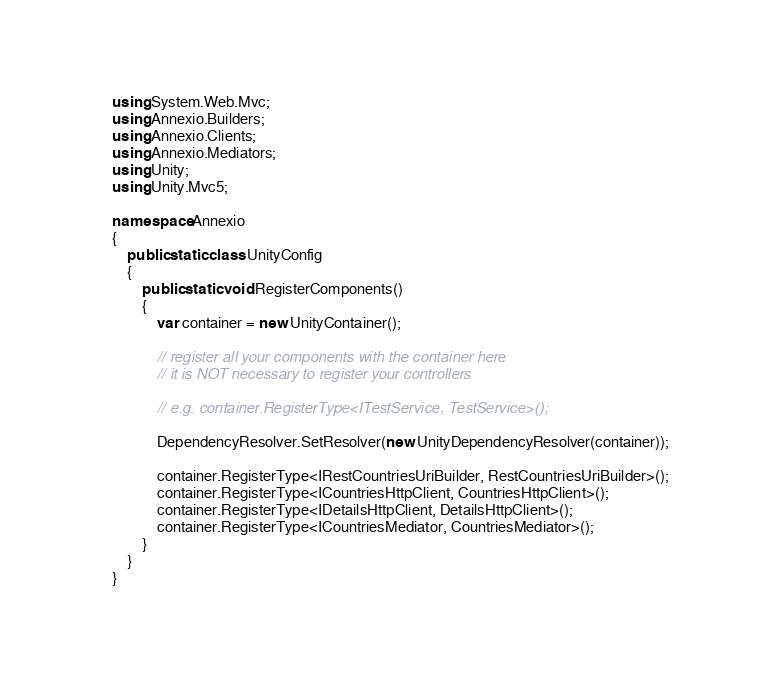<code> <loc_0><loc_0><loc_500><loc_500><_C#_>using System.Web.Mvc;
using Annexio.Builders;
using Annexio.Clients;
using Annexio.Mediators;
using Unity;
using Unity.Mvc5;

namespace Annexio
{
    public static class UnityConfig
    {
        public static void RegisterComponents()
        {
			var container = new UnityContainer();
            
            // register all your components with the container here
            // it is NOT necessary to register your controllers
            
            // e.g. container.RegisterType<ITestService, TestService>();
            
            DependencyResolver.SetResolver(new UnityDependencyResolver(container));

            container.RegisterType<IRestCountriesUriBuilder, RestCountriesUriBuilder>();
            container.RegisterType<ICountriesHttpClient, CountriesHttpClient>();
            container.RegisterType<IDetailsHttpClient, DetailsHttpClient>();
            container.RegisterType<ICountriesMediator, CountriesMediator>();
        }
    }
}</code> 